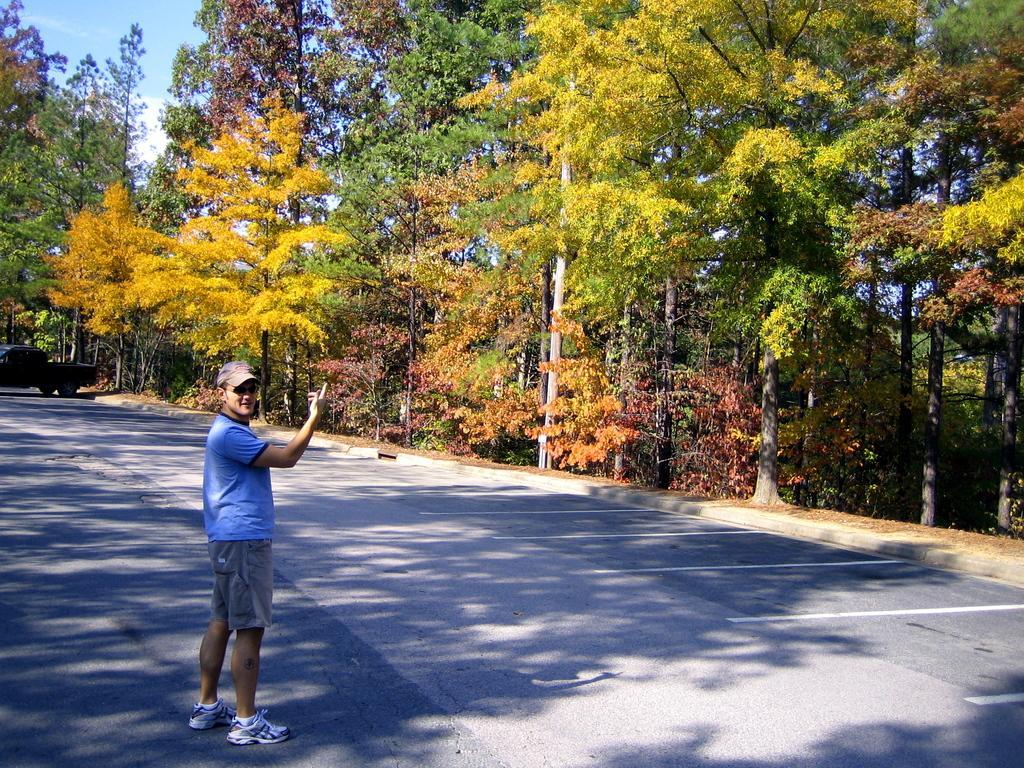In one or two sentences, can you explain what this image depicts? In the picture I can see a person wearing blue T-shirt is standing on the road and there is a vehicle in the left corner and there are few trees in the background. 